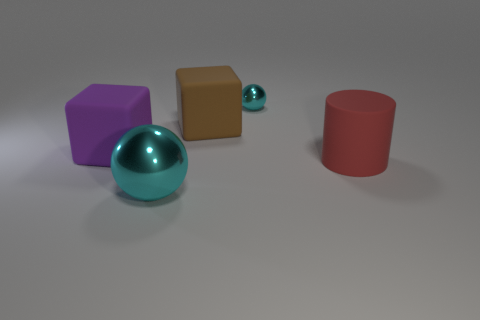The thing to the right of the metal sphere behind the big cube on the right side of the big purple matte block is made of what material?
Offer a very short reply. Rubber. How many cyan objects have the same size as the purple block?
Offer a terse response. 1. What is the object that is in front of the large purple matte thing and to the left of the small cyan metallic thing made of?
Give a very brief answer. Metal. What number of big red rubber things are behind the big red rubber thing?
Your answer should be very brief. 0. There is a large brown object; is its shape the same as the large matte thing to the left of the big sphere?
Offer a terse response. Yes. Is there another cyan metallic thing that has the same shape as the large cyan thing?
Make the answer very short. Yes. What is the shape of the large object right of the cyan object that is behind the big brown thing?
Offer a terse response. Cylinder. The shiny object on the right side of the big ball has what shape?
Your answer should be very brief. Sphere. There is a metal object in front of the large brown object; is it the same color as the shiny object on the right side of the brown rubber thing?
Give a very brief answer. Yes. How many spheres are both behind the big cyan shiny ball and in front of the small ball?
Give a very brief answer. 0. 